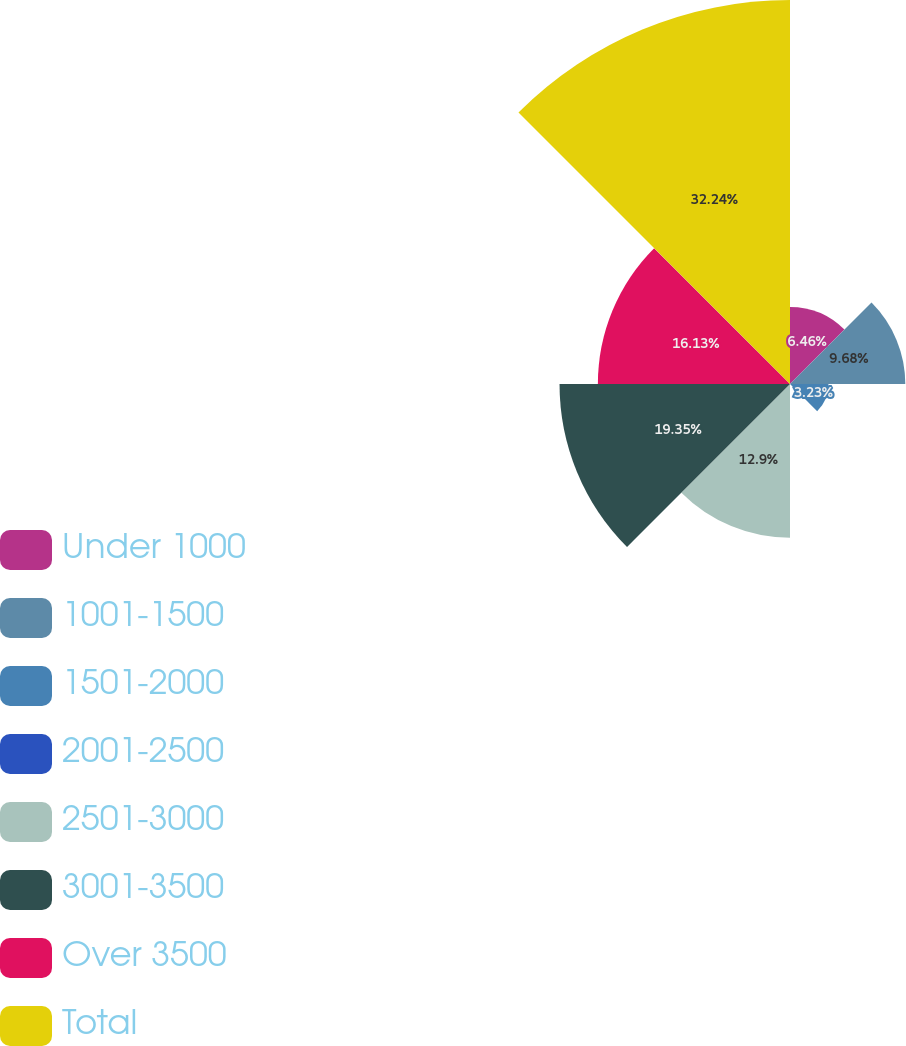Convert chart. <chart><loc_0><loc_0><loc_500><loc_500><pie_chart><fcel>Under 1000<fcel>1001-1500<fcel>1501-2000<fcel>2001-2500<fcel>2501-3000<fcel>3001-3500<fcel>Over 3500<fcel>Total<nl><fcel>6.46%<fcel>9.68%<fcel>3.23%<fcel>0.01%<fcel>12.9%<fcel>19.35%<fcel>16.13%<fcel>32.24%<nl></chart> 